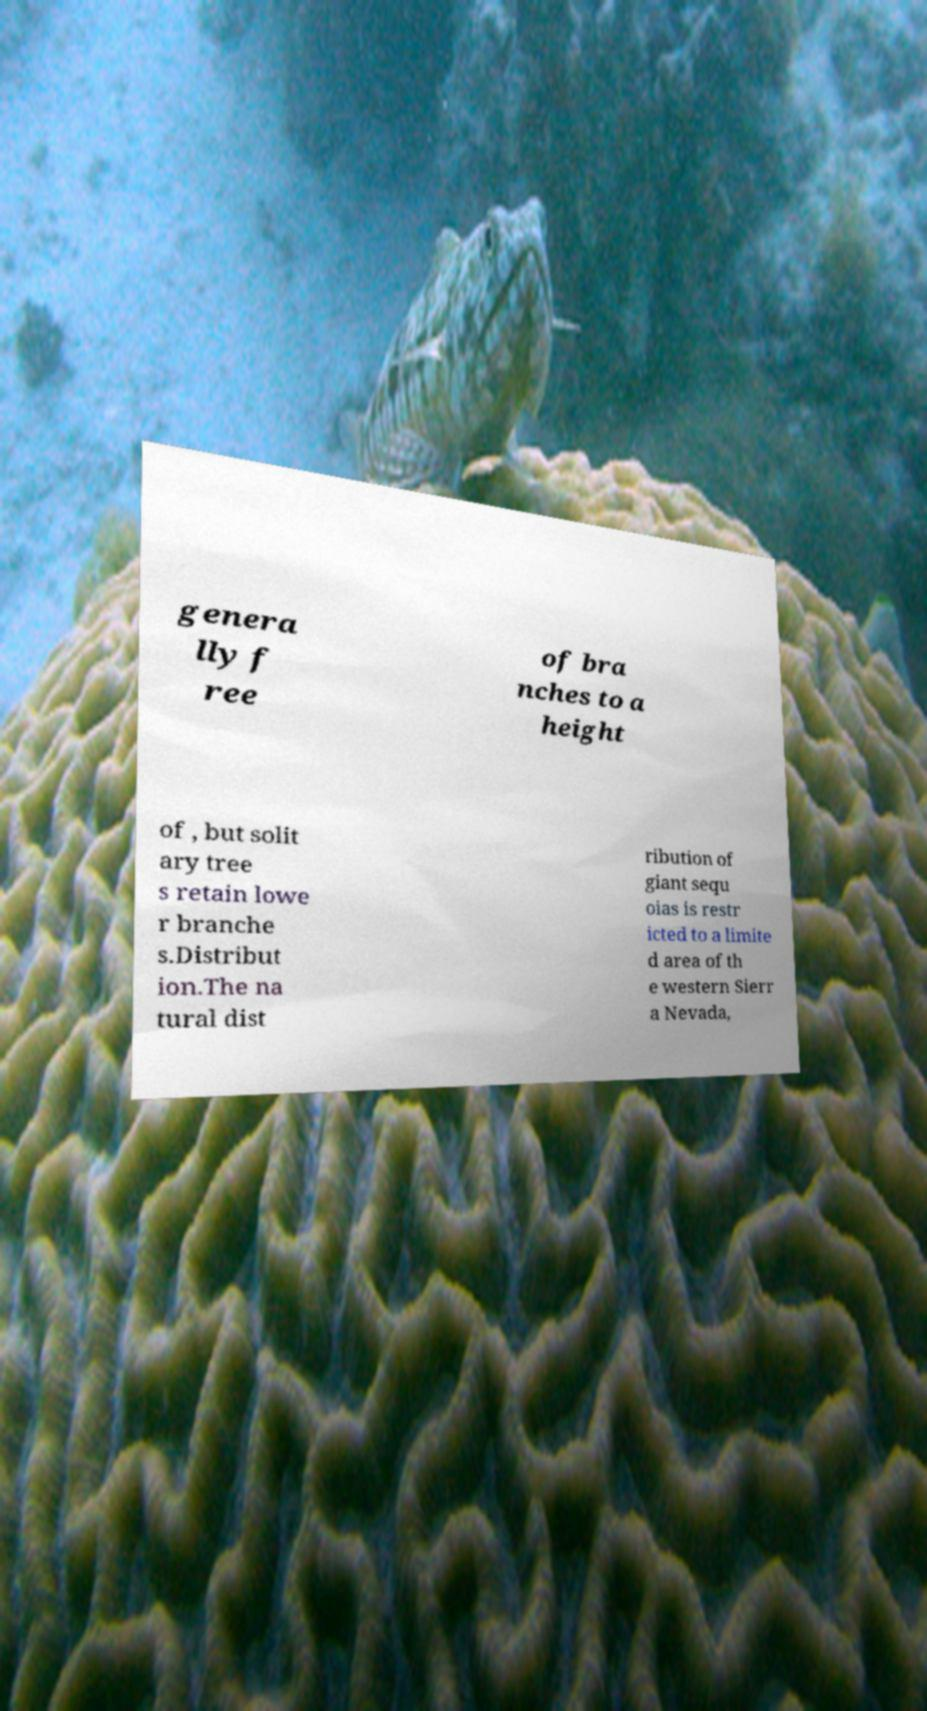I need the written content from this picture converted into text. Can you do that? genera lly f ree of bra nches to a height of , but solit ary tree s retain lowe r branche s.Distribut ion.The na tural dist ribution of giant sequ oias is restr icted to a limite d area of th e western Sierr a Nevada, 